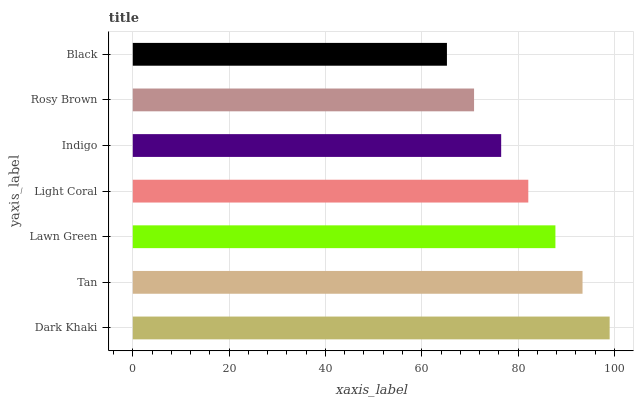Is Black the minimum?
Answer yes or no. Yes. Is Dark Khaki the maximum?
Answer yes or no. Yes. Is Tan the minimum?
Answer yes or no. No. Is Tan the maximum?
Answer yes or no. No. Is Dark Khaki greater than Tan?
Answer yes or no. Yes. Is Tan less than Dark Khaki?
Answer yes or no. Yes. Is Tan greater than Dark Khaki?
Answer yes or no. No. Is Dark Khaki less than Tan?
Answer yes or no. No. Is Light Coral the high median?
Answer yes or no. Yes. Is Light Coral the low median?
Answer yes or no. Yes. Is Tan the high median?
Answer yes or no. No. Is Indigo the low median?
Answer yes or no. No. 